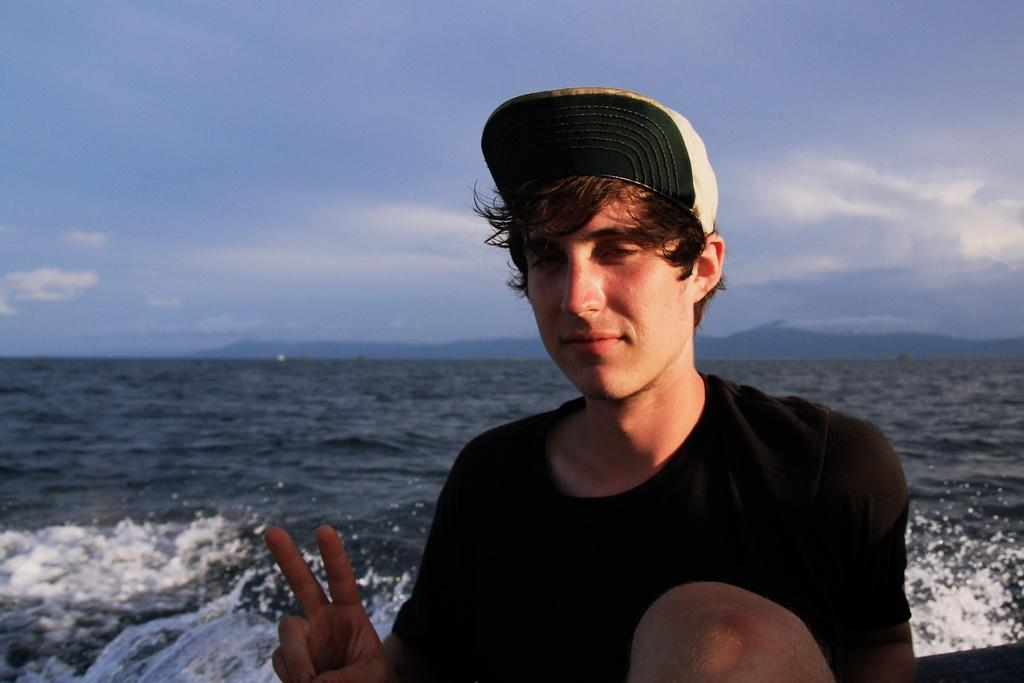What is present in the image? There is a man in the image. What is the man doing with his fingers? The man is showing his fingers in the image. What can be seen in the background of the image? There is water visible in the background of the image. What type of boat can be seen in the image? There is no boat present in the image; it only features a man showing his fingers and water in the background. What kind of offer is the man making in the image? There is no indication of an offer being made in the image; the man is simply showing his fingers. 